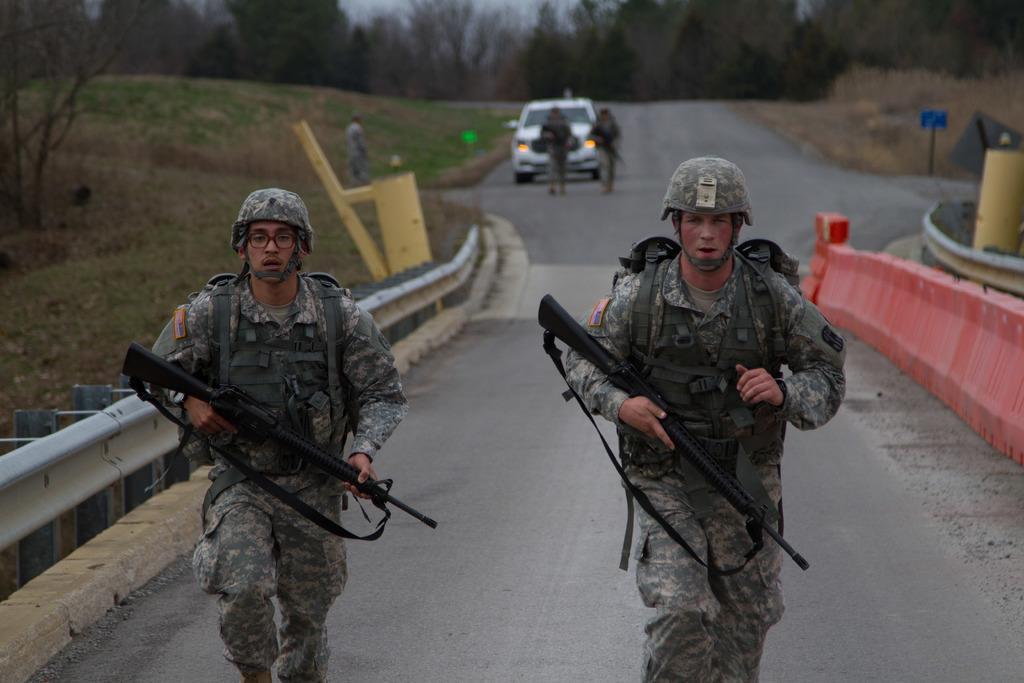Describe this image in one or two sentences. In this image I can see two people are running and wearing the military uniforms. These people are holding the weapons which are in black color. To the side I can see the fence. In the back I can see few more people and the white car. I can also see the many trees and the sky in the back. 